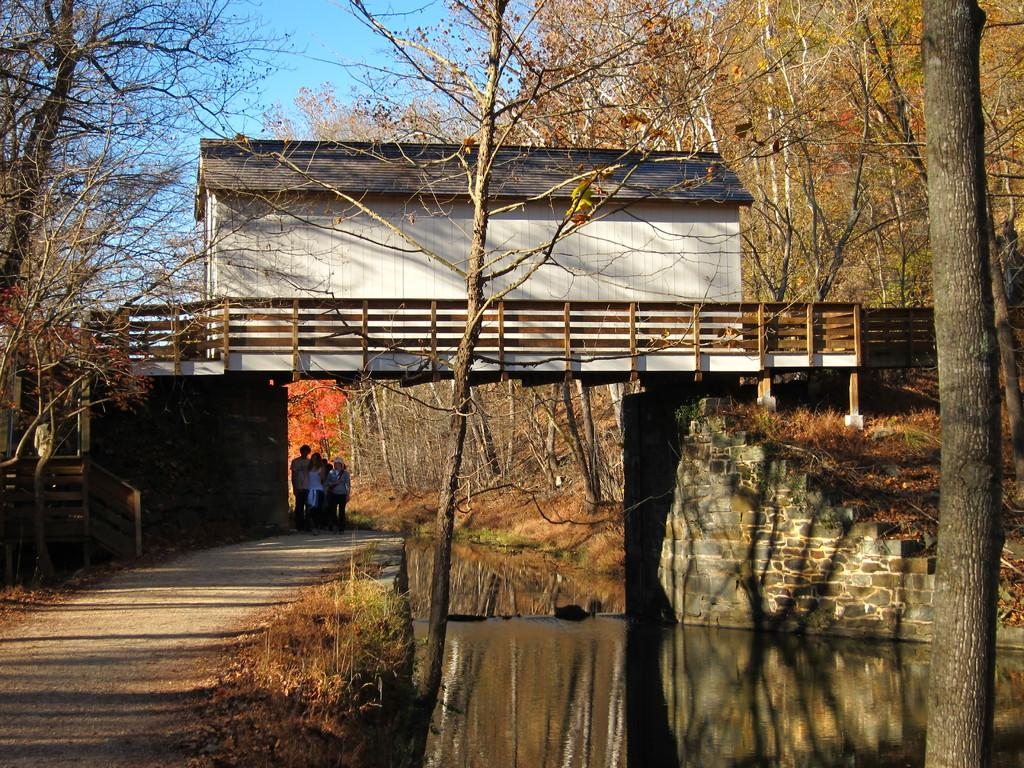What type of structure is located on the bridge in the image? There is a house on a bridge in the image. What can be seen under the bridge in the image? There are people standing under the bridge in the image. What type of vegetation is visible in the image? There are trees visible in the image. What natural element is present in the image? There is water visible in the image. How many dolls are being distributed by the squirrel in the image? There are no dolls or squirrels present in the image. 